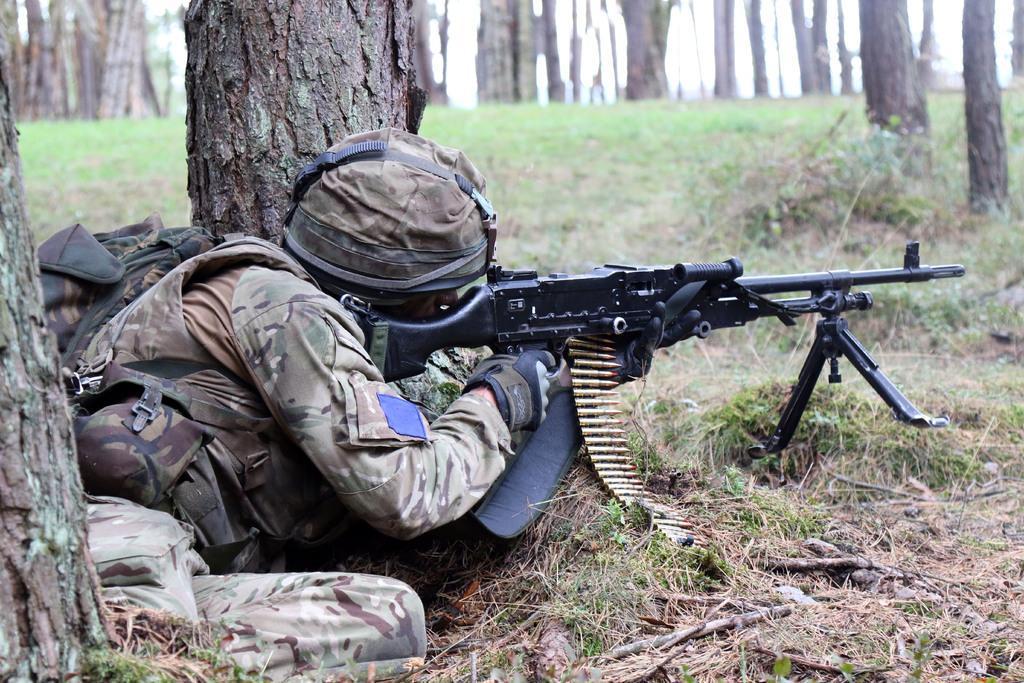Please provide a concise description of this image. Here there is a grass. Soldier is laying on the floor targeting with this gun. There are trees around him. 